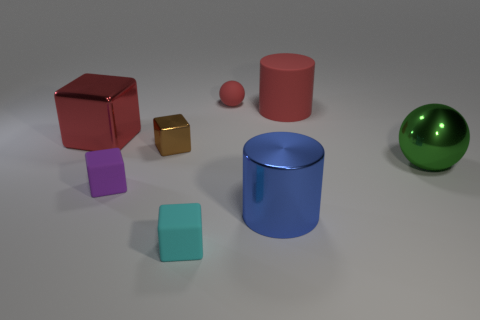Add 1 cyan blocks. How many objects exist? 9 Subtract all balls. How many objects are left? 6 Subtract 0 blue balls. How many objects are left? 8 Subtract all tiny cyan cubes. Subtract all tiny red blocks. How many objects are left? 7 Add 4 small purple matte blocks. How many small purple matte blocks are left? 5 Add 7 big purple shiny blocks. How many big purple shiny blocks exist? 7 